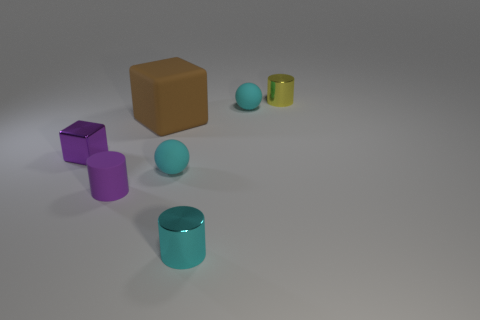Are there any other things that are the same size as the brown block?
Provide a short and direct response. No. Do the rubber cube and the tiny block have the same color?
Your answer should be compact. No. How many cylinders are small yellow things or large brown matte objects?
Provide a short and direct response. 1. What is the small object that is both behind the small metallic block and in front of the small yellow object made of?
Your answer should be compact. Rubber. How many yellow things are in front of the matte cylinder?
Give a very brief answer. 0. Do the tiny cyan sphere that is in front of the tiny purple metal cube and the purple block that is left of the big cube have the same material?
Make the answer very short. No. What number of things are either tiny cyan shiny cylinders that are in front of the purple block or tiny yellow cylinders?
Provide a succinct answer. 2. Are there fewer yellow metallic things that are in front of the cyan cylinder than brown cubes that are behind the tiny yellow thing?
Keep it short and to the point. No. What number of other objects are there of the same size as the brown matte cube?
Give a very brief answer. 0. Does the tiny cube have the same material as the tiny ball in front of the large thing?
Give a very brief answer. No. 